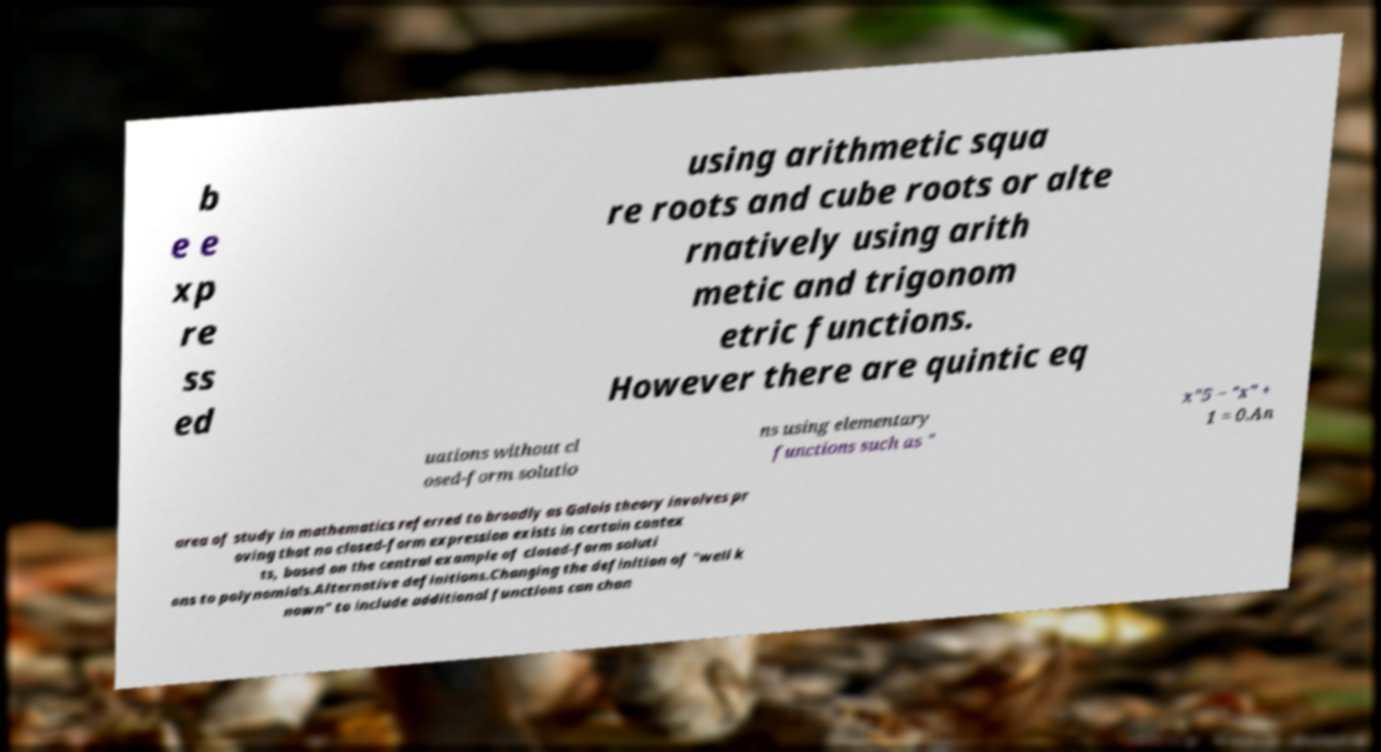I need the written content from this picture converted into text. Can you do that? b e e xp re ss ed using arithmetic squa re roots and cube roots or alte rnatively using arith metic and trigonom etric functions. However there are quintic eq uations without cl osed-form solutio ns using elementary functions such as " x"5 − "x" + 1 = 0.An area of study in mathematics referred to broadly as Galois theory involves pr oving that no closed-form expression exists in certain contex ts, based on the central example of closed-form soluti ons to polynomials.Alternative definitions.Changing the definition of "well k nown" to include additional functions can chan 